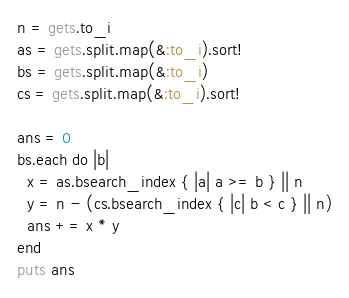Convert code to text. <code><loc_0><loc_0><loc_500><loc_500><_Ruby_>n = gets.to_i
as = gets.split.map(&:to_i).sort!
bs = gets.split.map(&:to_i)
cs = gets.split.map(&:to_i).sort!

ans = 0
bs.each do |b|
  x = as.bsearch_index { |a| a >= b } || n
  y = n - (cs.bsearch_index { |c| b < c } || n)
  ans += x * y
end
puts ans
</code> 